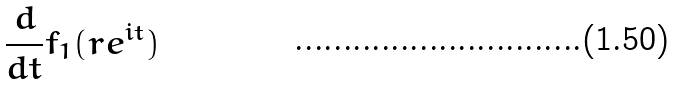Convert formula to latex. <formula><loc_0><loc_0><loc_500><loc_500>\frac { d } { d t } f _ { 1 } ( r e ^ { i t } )</formula> 